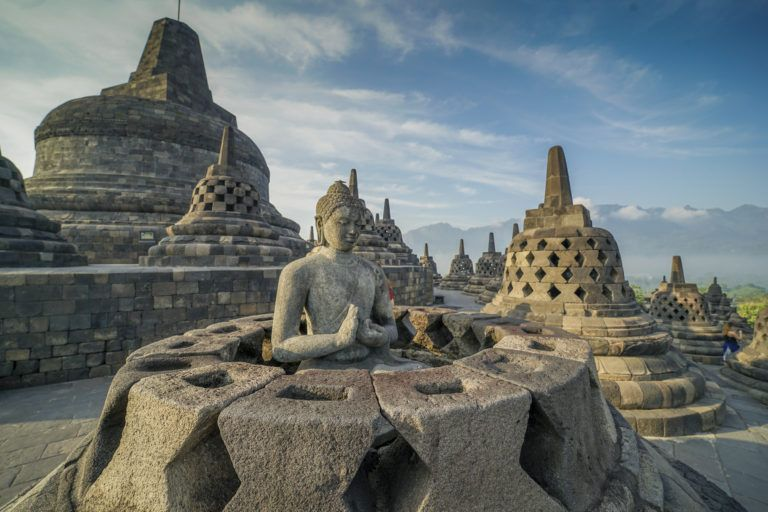What would it be like to meditate at Borobodur Temple? Meditating at Borobodur Temple would be an incredibly serene and transcendent experience. Picture sitting in lotus position atop one of the temple's platforms, surrounded by ancient, sacred stone. The air is cool and filled with the scents of earth and history. As you close your eyes and take deep breaths, the quietude of the temple envelops you, with only the soft rustling of leaves and distant bird calls breaking the silence. The presence of Buddha statues and stupas around you creates a sense of profound peace and spirituality. The slow rhythms of your breath align with the centuries-old heartbeat of the temple, fostering a deep connection with the past, present, and the timeless teachings of Buddhism. 